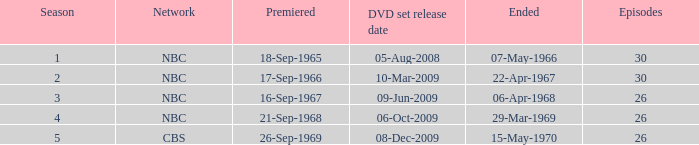What is the total season number for episodes later than episode 30? None. 